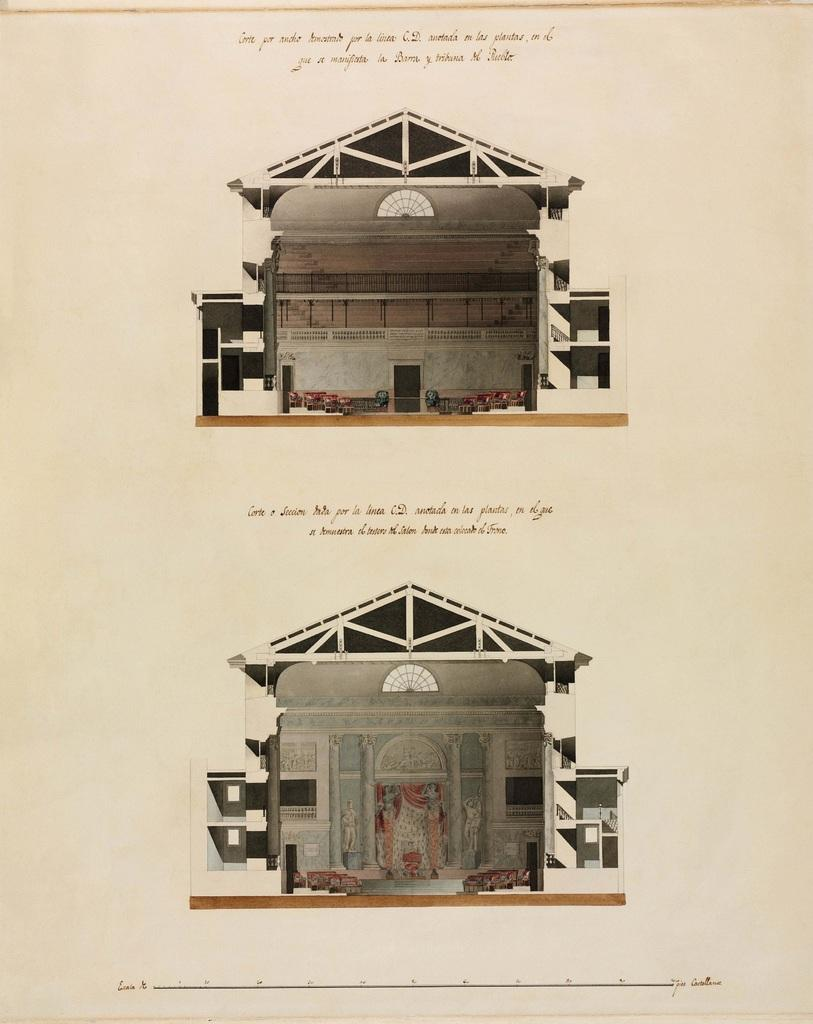What is depicted on the paper in the image? There are two buildings depicted on the paper. What else can be seen on the paper? There is text on the paper. What is the color of the background in the image? The background of the image is white in color. What is the purpose of the wall in the image? The purpose of the wall is not specified in the image, but it could be a structural element or a boundary. What type of mint is used as bait for the opinion in the image? There is no mint, bait, or opinion present in the image. 